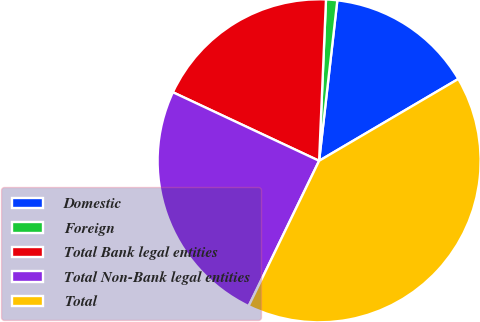Convert chart to OTSL. <chart><loc_0><loc_0><loc_500><loc_500><pie_chart><fcel>Domestic<fcel>Foreign<fcel>Total Bank legal entities<fcel>Total Non-Bank legal entities<fcel>Total<nl><fcel>14.74%<fcel>1.12%<fcel>18.7%<fcel>24.79%<fcel>40.65%<nl></chart> 